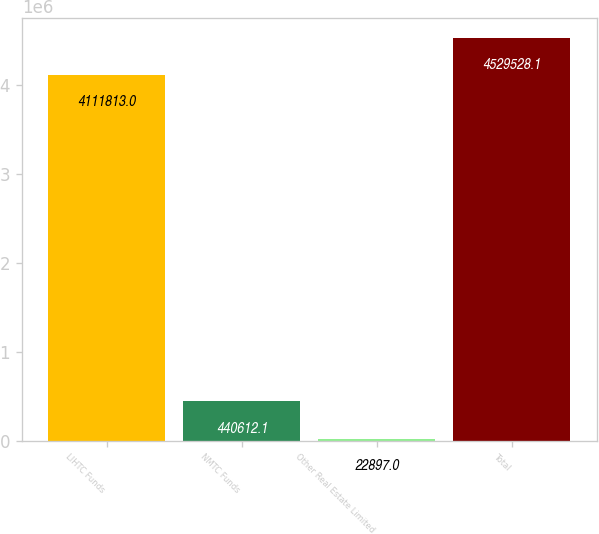Convert chart to OTSL. <chart><loc_0><loc_0><loc_500><loc_500><bar_chart><fcel>LIHTC Funds<fcel>NMTC Funds<fcel>Other Real Estate Limited<fcel>Total<nl><fcel>4.11181e+06<fcel>440612<fcel>22897<fcel>4.52953e+06<nl></chart> 